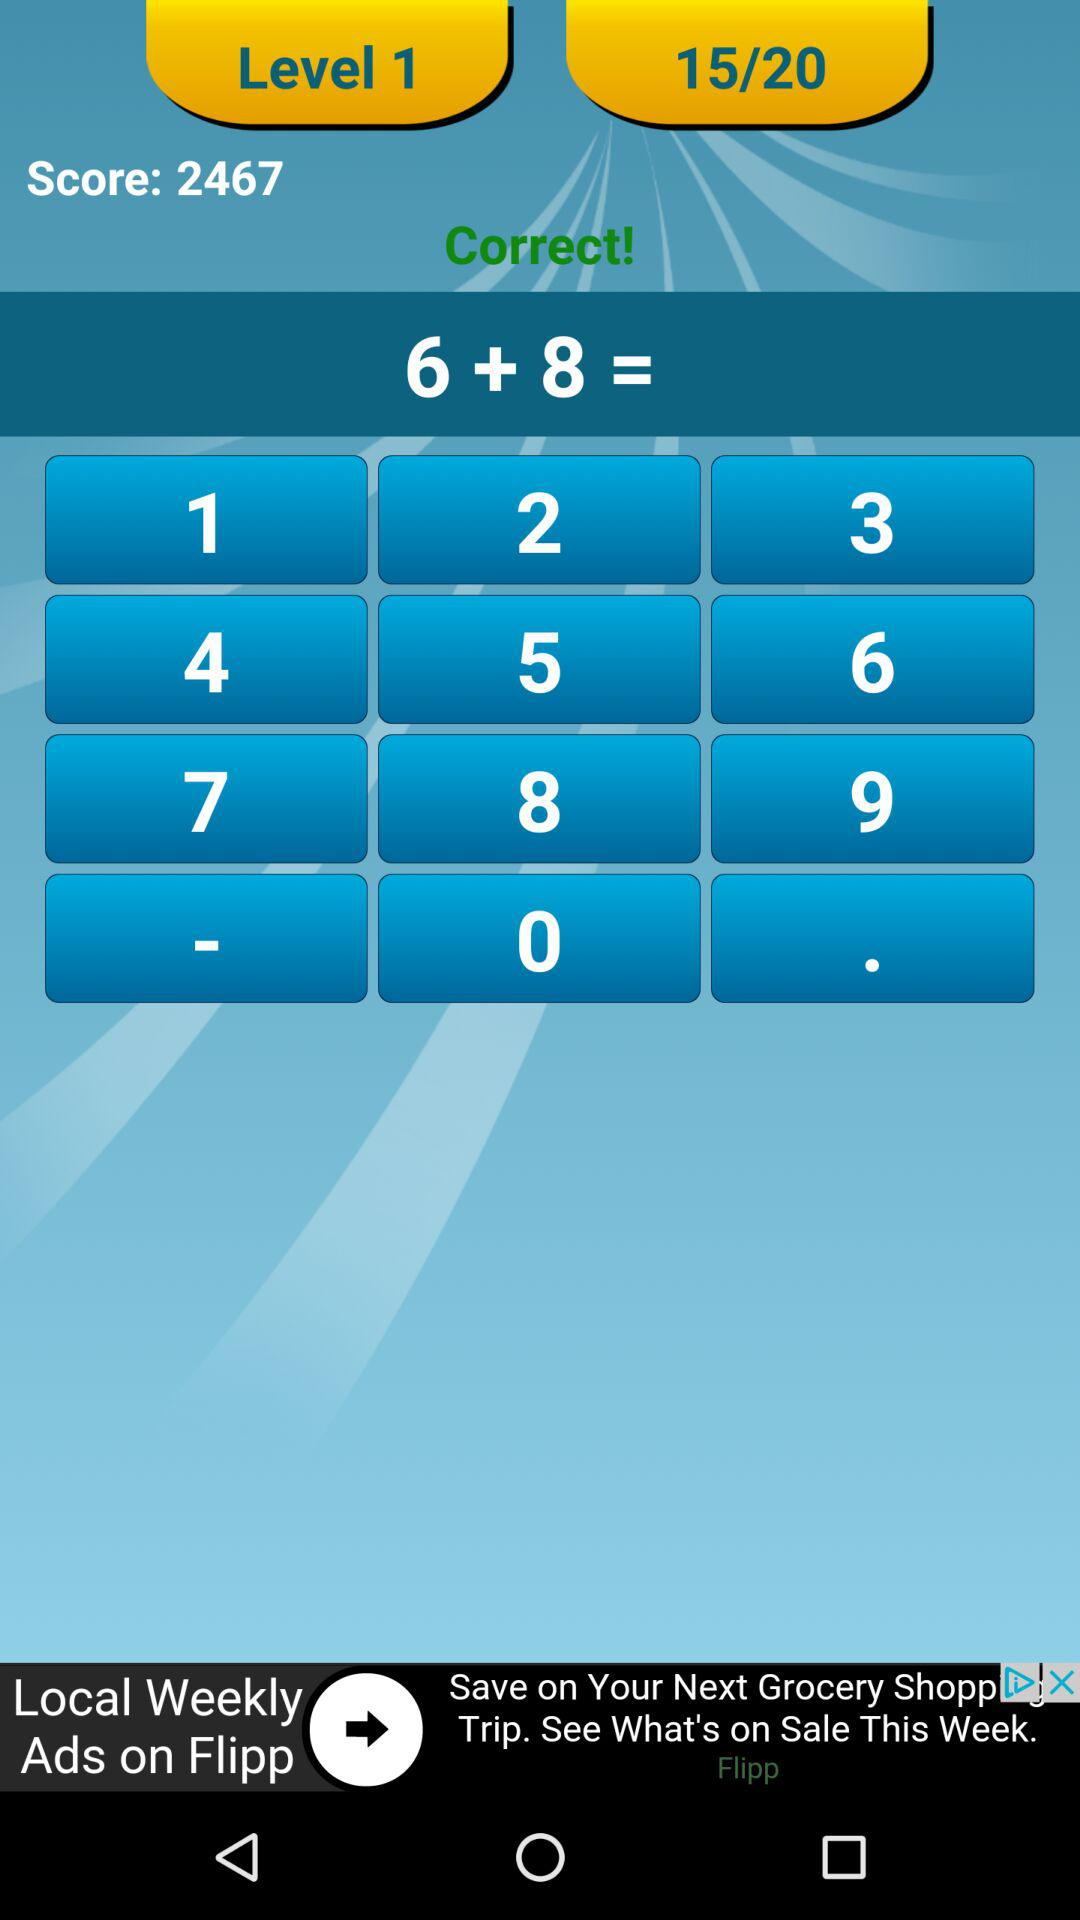What is the answer to the math problem?
Answer the question using a single word or phrase. 14 